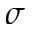Convert formula to latex. <formula><loc_0><loc_0><loc_500><loc_500>\sigma</formula> 